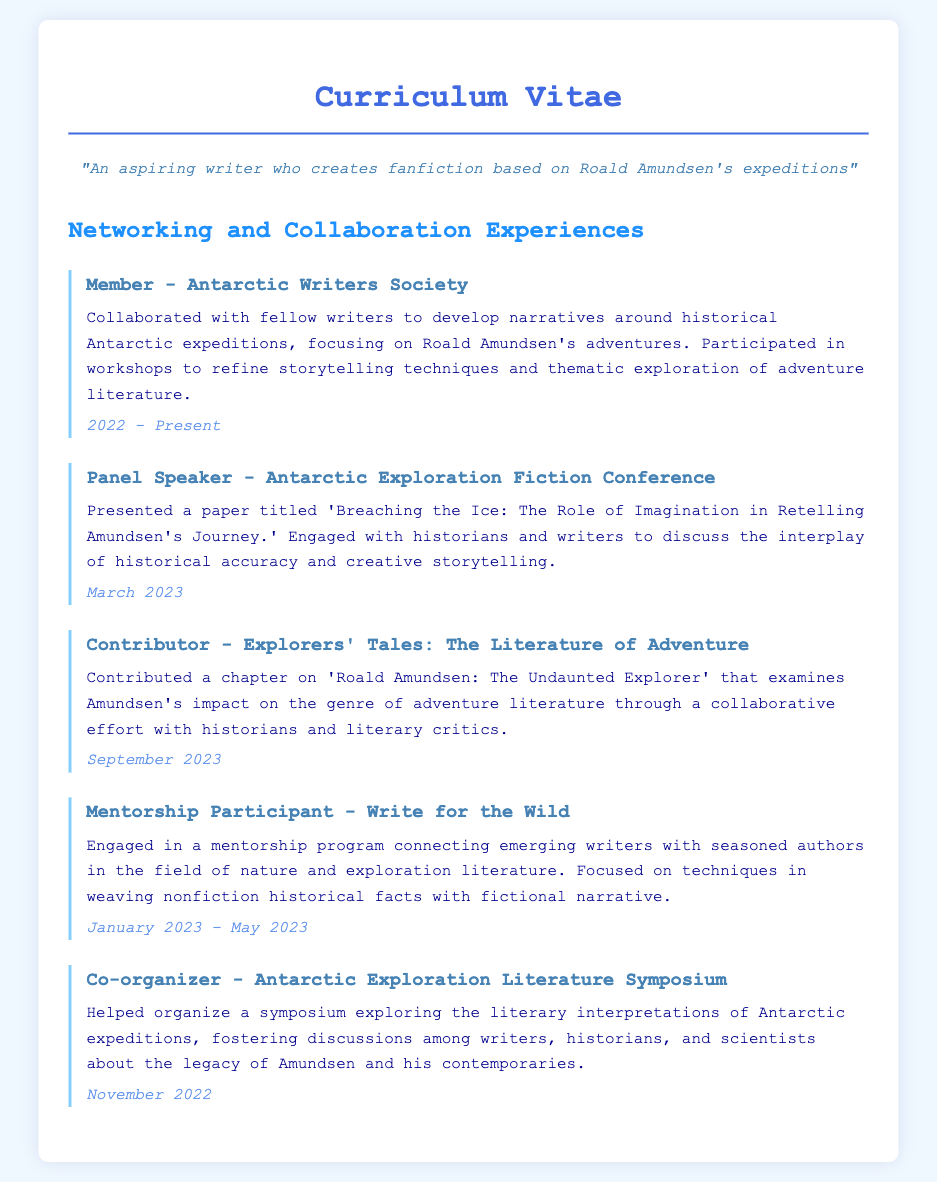What is the name of the society the writer is a member of? The document states that the writer is a member of the Antarctic Writers Society.
Answer: Antarctic Writers Society In which month and year did the writer present at the Antarctic Exploration Fiction Conference? The document specifies that the presentation occurred in March 2023.
Answer: March 2023 What is the title of the chapter contributed by the writer? The document includes the chapter title 'Roald Amundsen: The Undaunted Explorer.'
Answer: Roald Amundsen: The Undaunted Explorer How long did the mentorship program 'Write for the Wild' last? The document indicates that the program lasted from January 2023 to May 2023, which is approximately 5 months.
Answer: 5 months What was the role of the writer in the Antarctic Exploration Literature Symposium? According to the document, the writer was a co-organizer of the symposium.
Answer: Co-organizer What year did the Antarctic Exploration Literature Symposium take place? The document mentions that the symposium took place in November 2022.
Answer: November 2022 